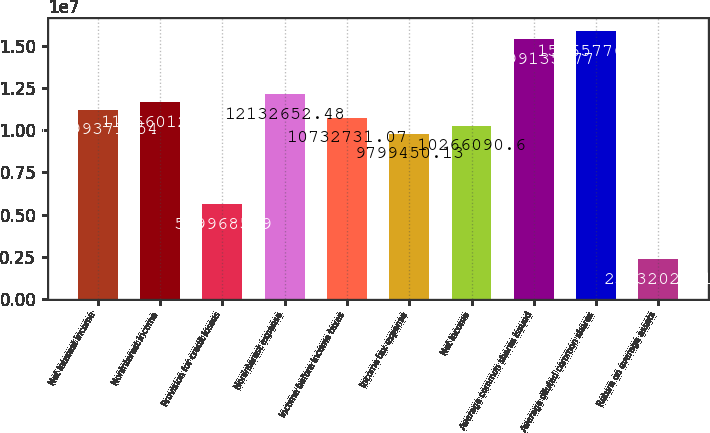<chart> <loc_0><loc_0><loc_500><loc_500><bar_chart><fcel>Net interest income<fcel>Noninterest income<fcel>Provision for credit losses<fcel>Noninterest expense<fcel>Income before income taxes<fcel>Income tax expense<fcel>Net income<fcel>Average common shares issued<fcel>Average diluted common shares<fcel>Return on average assets<nl><fcel>1.11994e+07<fcel>1.1666e+07<fcel>5.59969e+06<fcel>1.21327e+07<fcel>1.07327e+07<fcel>9.79945e+06<fcel>1.02661e+07<fcel>1.53991e+07<fcel>1.58658e+07<fcel>2.3332e+06<nl></chart> 